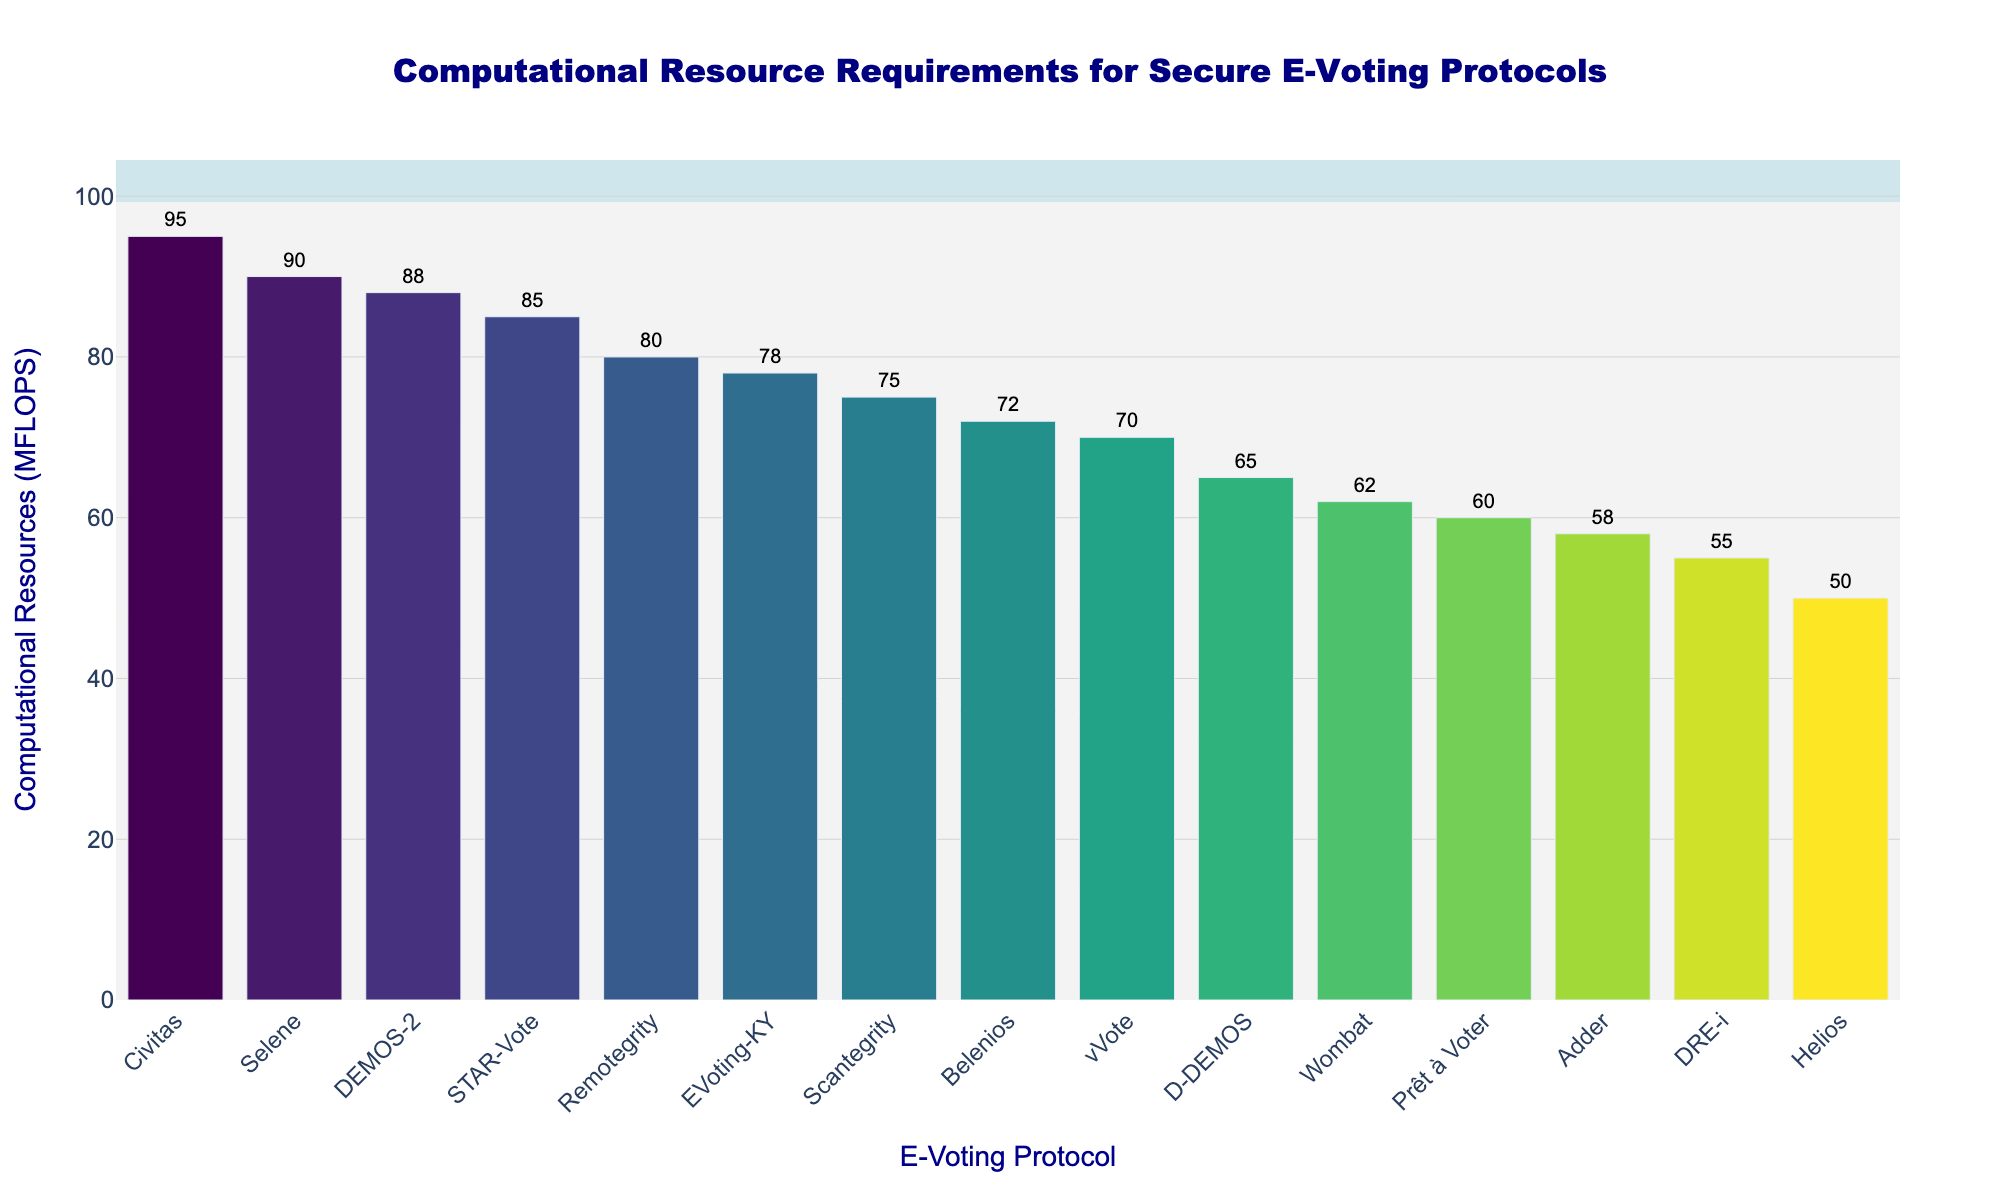What is the highest computational resource requirement among the protocols? To find the highest computational resource requirement, observe the bar with the maximum height on the bar chart. The tallest bar represents Civitas, which has a computational resource requirement of 95 MFLOPS.
Answer: 95 MFLOPS Which protocol has the lowest computational resource requirement? To determine the protocol with the lowest computational resource requirement, look for the shortest bar on the bar chart. The shortest bar corresponds to Helios, which has a computational resource requirement of 50 MFLOPS.
Answer: Helios How many protocols have computational resource requirements above 70 MFLOPS? Count the number of bars that extend above the 70 MFLOPS mark. The protocols exceeding 70 MFLOPS are Scantegrity, STAR-Vote, Remotegrity, Civitas, Selene, Belenios, DEMOS-2, and EVoting-KY. There are 8 such protocols.
Answer: 8 Which protocol has a higher computational resource requirement, Prêt à Voter or Wombat? Compare the heights of the bars for Prêt à Voter and Wombat. Prêt à Voter's bar reaches 60 MFLOPS, while Wombat’s bar reaches 62 MFLOPS. Therefore, Wombat has a higher computational resource requirement.
Answer: Wombat What is the combined computational resource requirement of D-DEMOS and Adder? Find the resource requirements for D-DEMOS and Adder, which are 65 MFLOPS and 58 MFLOPS, respectively. Add these values: 65 + 58 = 123 MFLOPS.
Answer: 123 MFLOPS What is the average computational resource requirement of the top 3 protocols? Identify the top 3 protocols with the highest resource requirements: Civitas (95 MFLOPS), Selene (90 MFLOPS), and DEMOS-2 (88 MFLOPS). Calculate their average: (95 + 90 + 88) / 3 = 91 MFLOPS.
Answer: 91 MFLOPS Which protocol shows the most significant difference in computational resource requirement when compared to Helios? To find the most significant difference, compare the computational resource requirements of each protocol with Helios (50 MFLOPS). Civitas, with 95 MFLOPS, shows the largest difference: 95 - 50 = 45 MFLOPS.
Answer: Civitas Are there more protocols requiring less than 70 MFLOPS or more than 70 MFLOPS? Count the protocols requiring less than 70 MFLOPS (Helios, Prêt à Voter, vVote, DRE-i, Belenios, Adder, Wombat, D-DEMOS) and those requiring more than 70 MFLOPS (Scantegrity, STAR-Vote, Civitas, Remotegrity, Selene, DEMOS-2, EVoting-KY). There are 8 protocols requiring less than 70 MFLOPS and 7 protocols requiring more than 70 MFLOPS.
Answer: Less than 70 MFLOPS 